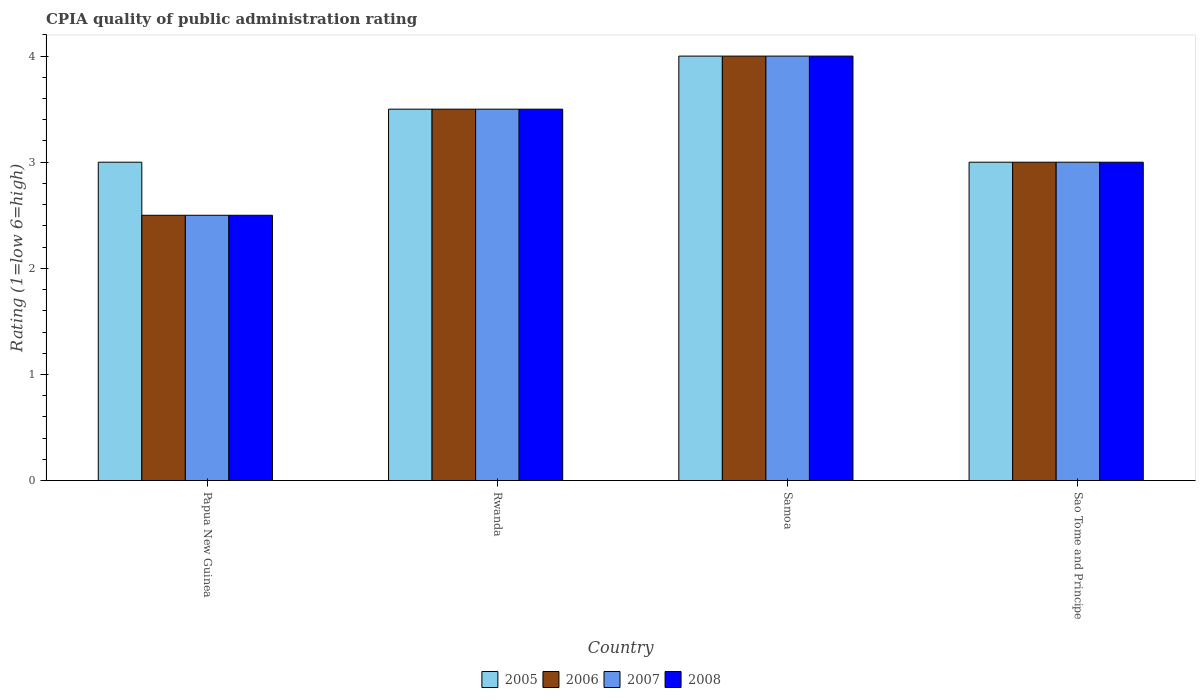How many different coloured bars are there?
Provide a succinct answer. 4. How many groups of bars are there?
Make the answer very short. 4. How many bars are there on the 3rd tick from the left?
Offer a very short reply. 4. How many bars are there on the 2nd tick from the right?
Provide a short and direct response. 4. What is the label of the 4th group of bars from the left?
Offer a terse response. Sao Tome and Principe. Across all countries, what is the maximum CPIA rating in 2007?
Your response must be concise. 4. Across all countries, what is the minimum CPIA rating in 2005?
Ensure brevity in your answer.  3. In which country was the CPIA rating in 2006 maximum?
Provide a succinct answer. Samoa. In which country was the CPIA rating in 2007 minimum?
Offer a very short reply. Papua New Guinea. What is the average CPIA rating in 2006 per country?
Your answer should be very brief. 3.25. In how many countries, is the CPIA rating in 2007 greater than 0.4?
Ensure brevity in your answer.  4. What is the ratio of the CPIA rating in 2007 in Papua New Guinea to that in Rwanda?
Your answer should be compact. 0.71. Is the difference between the CPIA rating in 2005 in Rwanda and Sao Tome and Principe greater than the difference between the CPIA rating in 2008 in Rwanda and Sao Tome and Principe?
Ensure brevity in your answer.  No. What is the difference between the highest and the second highest CPIA rating in 2008?
Offer a very short reply. -0.5. What is the difference between the highest and the lowest CPIA rating in 2006?
Your answer should be very brief. 1.5. Is the sum of the CPIA rating in 2007 in Rwanda and Sao Tome and Principe greater than the maximum CPIA rating in 2006 across all countries?
Give a very brief answer. Yes. What does the 1st bar from the left in Sao Tome and Principe represents?
Provide a succinct answer. 2005. What does the 1st bar from the right in Rwanda represents?
Provide a succinct answer. 2008. Is it the case that in every country, the sum of the CPIA rating in 2005 and CPIA rating in 2007 is greater than the CPIA rating in 2006?
Your answer should be very brief. Yes. Are the values on the major ticks of Y-axis written in scientific E-notation?
Make the answer very short. No. Does the graph contain grids?
Your response must be concise. No. How many legend labels are there?
Make the answer very short. 4. What is the title of the graph?
Your answer should be very brief. CPIA quality of public administration rating. What is the label or title of the Y-axis?
Keep it short and to the point. Rating (1=low 6=high). What is the Rating (1=low 6=high) of 2008 in Papua New Guinea?
Your answer should be very brief. 2.5. What is the Rating (1=low 6=high) of 2005 in Rwanda?
Offer a terse response. 3.5. What is the Rating (1=low 6=high) in 2007 in Rwanda?
Your response must be concise. 3.5. What is the Rating (1=low 6=high) of 2008 in Rwanda?
Ensure brevity in your answer.  3.5. What is the Rating (1=low 6=high) of 2005 in Sao Tome and Principe?
Your response must be concise. 3. Across all countries, what is the maximum Rating (1=low 6=high) of 2005?
Keep it short and to the point. 4. Across all countries, what is the maximum Rating (1=low 6=high) of 2006?
Offer a terse response. 4. Across all countries, what is the maximum Rating (1=low 6=high) in 2007?
Provide a succinct answer. 4. Across all countries, what is the minimum Rating (1=low 6=high) in 2007?
Offer a terse response. 2.5. Across all countries, what is the minimum Rating (1=low 6=high) in 2008?
Make the answer very short. 2.5. What is the difference between the Rating (1=low 6=high) in 2006 in Papua New Guinea and that in Rwanda?
Ensure brevity in your answer.  -1. What is the difference between the Rating (1=low 6=high) of 2007 in Papua New Guinea and that in Rwanda?
Your answer should be very brief. -1. What is the difference between the Rating (1=low 6=high) of 2005 in Papua New Guinea and that in Samoa?
Your answer should be compact. -1. What is the difference between the Rating (1=low 6=high) of 2006 in Papua New Guinea and that in Samoa?
Your answer should be very brief. -1.5. What is the difference between the Rating (1=low 6=high) of 2007 in Papua New Guinea and that in Samoa?
Your answer should be compact. -1.5. What is the difference between the Rating (1=low 6=high) of 2008 in Papua New Guinea and that in Samoa?
Provide a short and direct response. -1.5. What is the difference between the Rating (1=low 6=high) in 2006 in Papua New Guinea and that in Sao Tome and Principe?
Give a very brief answer. -0.5. What is the difference between the Rating (1=low 6=high) in 2005 in Rwanda and that in Samoa?
Provide a succinct answer. -0.5. What is the difference between the Rating (1=low 6=high) in 2006 in Rwanda and that in Samoa?
Ensure brevity in your answer.  -0.5. What is the difference between the Rating (1=low 6=high) in 2007 in Rwanda and that in Samoa?
Make the answer very short. -0.5. What is the difference between the Rating (1=low 6=high) in 2008 in Rwanda and that in Samoa?
Provide a short and direct response. -0.5. What is the difference between the Rating (1=low 6=high) of 2005 in Rwanda and that in Sao Tome and Principe?
Provide a short and direct response. 0.5. What is the difference between the Rating (1=low 6=high) in 2006 in Rwanda and that in Sao Tome and Principe?
Make the answer very short. 0.5. What is the difference between the Rating (1=low 6=high) in 2008 in Rwanda and that in Sao Tome and Principe?
Your answer should be very brief. 0.5. What is the difference between the Rating (1=low 6=high) of 2005 in Samoa and that in Sao Tome and Principe?
Your response must be concise. 1. What is the difference between the Rating (1=low 6=high) of 2008 in Samoa and that in Sao Tome and Principe?
Offer a very short reply. 1. What is the difference between the Rating (1=low 6=high) of 2005 in Papua New Guinea and the Rating (1=low 6=high) of 2008 in Rwanda?
Offer a terse response. -0.5. What is the difference between the Rating (1=low 6=high) of 2006 in Papua New Guinea and the Rating (1=low 6=high) of 2007 in Rwanda?
Make the answer very short. -1. What is the difference between the Rating (1=low 6=high) of 2007 in Papua New Guinea and the Rating (1=low 6=high) of 2008 in Rwanda?
Provide a short and direct response. -1. What is the difference between the Rating (1=low 6=high) in 2005 in Papua New Guinea and the Rating (1=low 6=high) in 2006 in Samoa?
Offer a very short reply. -1. What is the difference between the Rating (1=low 6=high) of 2005 in Papua New Guinea and the Rating (1=low 6=high) of 2007 in Samoa?
Your answer should be very brief. -1. What is the difference between the Rating (1=low 6=high) of 2005 in Papua New Guinea and the Rating (1=low 6=high) of 2008 in Samoa?
Keep it short and to the point. -1. What is the difference between the Rating (1=low 6=high) in 2006 in Papua New Guinea and the Rating (1=low 6=high) in 2007 in Samoa?
Your answer should be very brief. -1.5. What is the difference between the Rating (1=low 6=high) of 2006 in Papua New Guinea and the Rating (1=low 6=high) of 2008 in Samoa?
Give a very brief answer. -1.5. What is the difference between the Rating (1=low 6=high) in 2007 in Papua New Guinea and the Rating (1=low 6=high) in 2008 in Samoa?
Keep it short and to the point. -1.5. What is the difference between the Rating (1=low 6=high) in 2005 in Papua New Guinea and the Rating (1=low 6=high) in 2007 in Sao Tome and Principe?
Ensure brevity in your answer.  0. What is the difference between the Rating (1=low 6=high) in 2005 in Papua New Guinea and the Rating (1=low 6=high) in 2008 in Sao Tome and Principe?
Provide a short and direct response. 0. What is the difference between the Rating (1=low 6=high) in 2006 in Papua New Guinea and the Rating (1=low 6=high) in 2007 in Sao Tome and Principe?
Give a very brief answer. -0.5. What is the difference between the Rating (1=low 6=high) of 2005 in Rwanda and the Rating (1=low 6=high) of 2006 in Samoa?
Ensure brevity in your answer.  -0.5. What is the difference between the Rating (1=low 6=high) of 2006 in Rwanda and the Rating (1=low 6=high) of 2007 in Samoa?
Give a very brief answer. -0.5. What is the difference between the Rating (1=low 6=high) in 2007 in Rwanda and the Rating (1=low 6=high) in 2008 in Samoa?
Offer a very short reply. -0.5. What is the difference between the Rating (1=low 6=high) of 2005 in Rwanda and the Rating (1=low 6=high) of 2007 in Sao Tome and Principe?
Offer a terse response. 0.5. What is the difference between the Rating (1=low 6=high) of 2005 in Rwanda and the Rating (1=low 6=high) of 2008 in Sao Tome and Principe?
Provide a succinct answer. 0.5. What is the difference between the Rating (1=low 6=high) of 2006 in Rwanda and the Rating (1=low 6=high) of 2007 in Sao Tome and Principe?
Give a very brief answer. 0.5. What is the difference between the Rating (1=low 6=high) in 2007 in Rwanda and the Rating (1=low 6=high) in 2008 in Sao Tome and Principe?
Give a very brief answer. 0.5. What is the difference between the Rating (1=low 6=high) of 2006 in Samoa and the Rating (1=low 6=high) of 2007 in Sao Tome and Principe?
Give a very brief answer. 1. What is the average Rating (1=low 6=high) of 2005 per country?
Provide a short and direct response. 3.38. What is the average Rating (1=low 6=high) in 2006 per country?
Ensure brevity in your answer.  3.25. What is the average Rating (1=low 6=high) of 2007 per country?
Provide a short and direct response. 3.25. What is the difference between the Rating (1=low 6=high) in 2005 and Rating (1=low 6=high) in 2006 in Papua New Guinea?
Your answer should be compact. 0.5. What is the difference between the Rating (1=low 6=high) of 2005 and Rating (1=low 6=high) of 2007 in Rwanda?
Offer a very short reply. 0. What is the difference between the Rating (1=low 6=high) in 2005 and Rating (1=low 6=high) in 2008 in Rwanda?
Ensure brevity in your answer.  0. What is the difference between the Rating (1=low 6=high) in 2006 and Rating (1=low 6=high) in 2007 in Rwanda?
Provide a short and direct response. 0. What is the difference between the Rating (1=low 6=high) in 2007 and Rating (1=low 6=high) in 2008 in Rwanda?
Keep it short and to the point. 0. What is the difference between the Rating (1=low 6=high) of 2006 and Rating (1=low 6=high) of 2007 in Samoa?
Your answer should be very brief. 0. What is the difference between the Rating (1=low 6=high) of 2007 and Rating (1=low 6=high) of 2008 in Samoa?
Your response must be concise. 0. What is the difference between the Rating (1=low 6=high) of 2005 and Rating (1=low 6=high) of 2007 in Sao Tome and Principe?
Make the answer very short. 0. What is the difference between the Rating (1=low 6=high) of 2005 and Rating (1=low 6=high) of 2008 in Sao Tome and Principe?
Your answer should be very brief. 0. What is the ratio of the Rating (1=low 6=high) in 2008 in Papua New Guinea to that in Rwanda?
Offer a terse response. 0.71. What is the ratio of the Rating (1=low 6=high) in 2006 in Papua New Guinea to that in Samoa?
Give a very brief answer. 0.62. What is the ratio of the Rating (1=low 6=high) of 2008 in Papua New Guinea to that in Samoa?
Your answer should be compact. 0.62. What is the ratio of the Rating (1=low 6=high) in 2005 in Papua New Guinea to that in Sao Tome and Principe?
Make the answer very short. 1. What is the ratio of the Rating (1=low 6=high) in 2006 in Papua New Guinea to that in Sao Tome and Principe?
Your answer should be compact. 0.83. What is the ratio of the Rating (1=low 6=high) of 2007 in Papua New Guinea to that in Sao Tome and Principe?
Offer a terse response. 0.83. What is the ratio of the Rating (1=low 6=high) in 2005 in Rwanda to that in Samoa?
Provide a short and direct response. 0.88. What is the ratio of the Rating (1=low 6=high) in 2006 in Rwanda to that in Samoa?
Ensure brevity in your answer.  0.88. What is the ratio of the Rating (1=low 6=high) of 2007 in Rwanda to that in Samoa?
Your answer should be very brief. 0.88. What is the ratio of the Rating (1=low 6=high) of 2005 in Rwanda to that in Sao Tome and Principe?
Keep it short and to the point. 1.17. What is the ratio of the Rating (1=low 6=high) of 2008 in Rwanda to that in Sao Tome and Principe?
Keep it short and to the point. 1.17. What is the ratio of the Rating (1=low 6=high) of 2005 in Samoa to that in Sao Tome and Principe?
Make the answer very short. 1.33. What is the difference between the highest and the second highest Rating (1=low 6=high) in 2008?
Offer a very short reply. 0.5. What is the difference between the highest and the lowest Rating (1=low 6=high) of 2005?
Your answer should be compact. 1. 